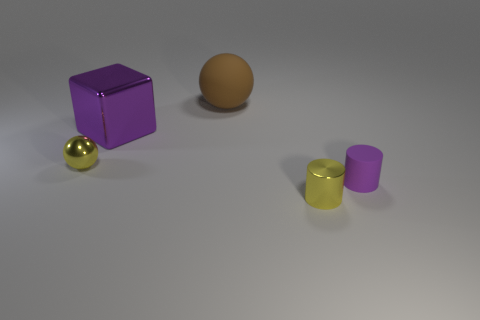Subtract all red blocks. Subtract all blue cylinders. How many blocks are left? 1 Add 4 purple matte objects. How many objects exist? 9 Subtract all spheres. How many objects are left? 3 Add 1 big brown objects. How many big brown objects are left? 2 Add 4 yellow shiny balls. How many yellow shiny balls exist? 5 Subtract 0 green cubes. How many objects are left? 5 Subtract all purple rubber objects. Subtract all tiny purple things. How many objects are left? 3 